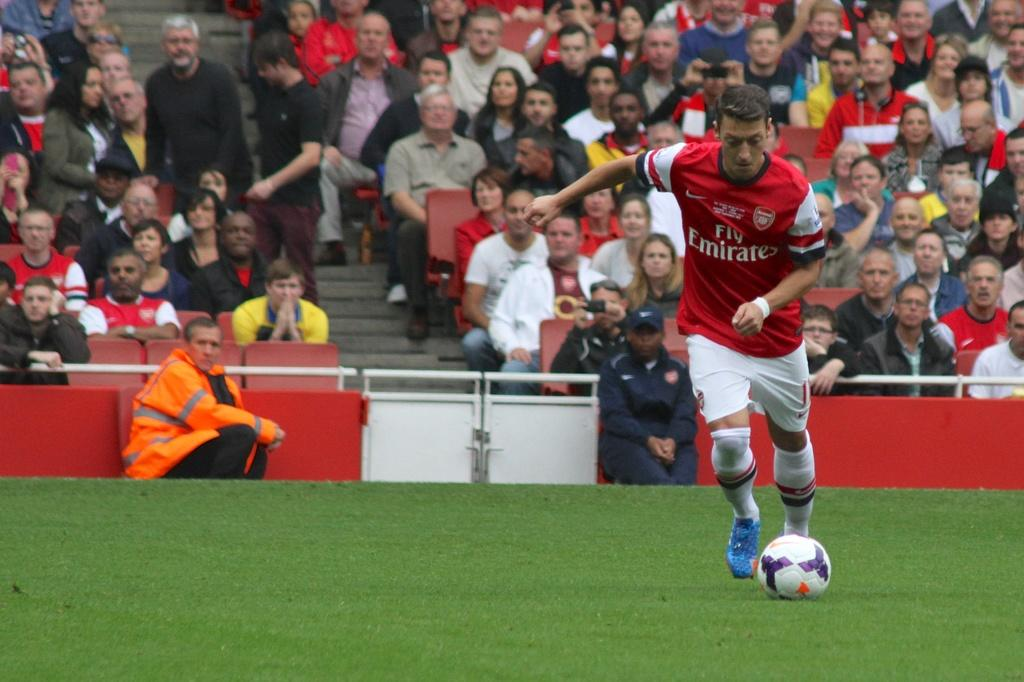Provide a one-sentence caption for the provided image. a man wearing a soccer jersey that says 'fly emirates' on it. 